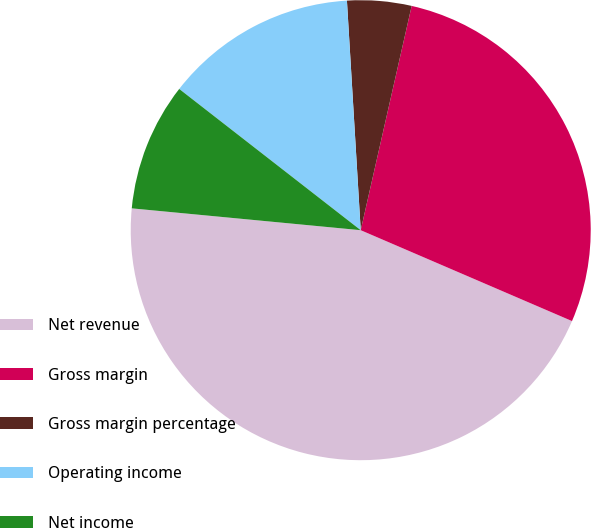Convert chart to OTSL. <chart><loc_0><loc_0><loc_500><loc_500><pie_chart><fcel>Net revenue<fcel>Gross margin<fcel>Gross margin percentage<fcel>Operating income<fcel>Net income<fcel>Diluted earnings per common<nl><fcel>45.05%<fcel>27.91%<fcel>4.51%<fcel>13.52%<fcel>9.01%<fcel>0.0%<nl></chart> 